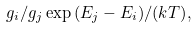<formula> <loc_0><loc_0><loc_500><loc_500>g _ { i } / g _ { j } \exp { ( E _ { j } - E _ { i } ) / ( k T ) } ,</formula> 